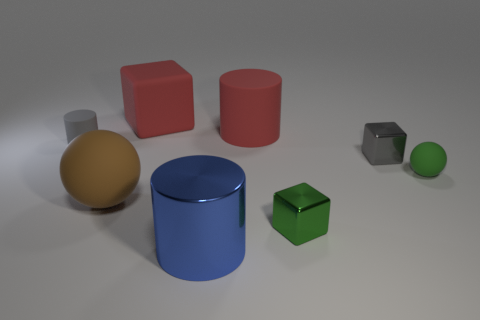Add 1 red objects. How many objects exist? 9 Subtract all small green metallic blocks. How many blocks are left? 2 Subtract all gray blocks. How many blocks are left? 2 Subtract 1 gray cubes. How many objects are left? 7 Subtract all spheres. How many objects are left? 6 Subtract 2 blocks. How many blocks are left? 1 Subtract all gray cubes. Subtract all purple balls. How many cubes are left? 2 Subtract all brown cubes. How many gray spheres are left? 0 Subtract all large rubber balls. Subtract all small gray things. How many objects are left? 5 Add 4 gray cylinders. How many gray cylinders are left? 5 